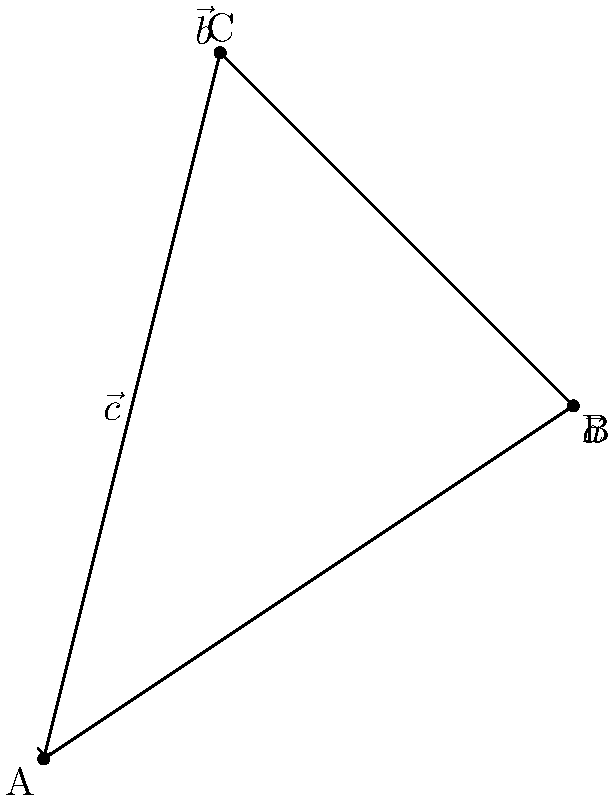In the diagram, vectors $\vec{a}$, $\vec{b}$, and $\vec{c}$ represent different screenplay ideas. If $\vec{c} = \vec{a} + \vec{b}$, what is the magnitude of vector $\vec{b}$? To find the magnitude of vector $\vec{b}$, we can follow these steps:

1) First, we need to determine the components of vectors $\vec{a}$ and $\vec{c}$:
   $\vec{a} = (3,2)$
   $\vec{c} = (1,4)$

2) Since $\vec{c} = \vec{a} + \vec{b}$, we can find $\vec{b}$ by subtracting $\vec{a}$ from $\vec{c}$:
   $\vec{b} = \vec{c} - \vec{a} = (1,4) - (3,2) = (-2,2)$

3) Now that we have the components of $\vec{b}$, we can calculate its magnitude using the Pythagorean theorem:
   $|\vec{b}| = \sqrt{(-2)^2 + 2^2}$

4) Simplify:
   $|\vec{b}| = \sqrt{4 + 4} = \sqrt{8}$

5) Simplify the square root:
   $|\vec{b}| = 2\sqrt{2}$

Therefore, the magnitude of vector $\vec{b}$ is $2\sqrt{2}$.
Answer: $2\sqrt{2}$ 